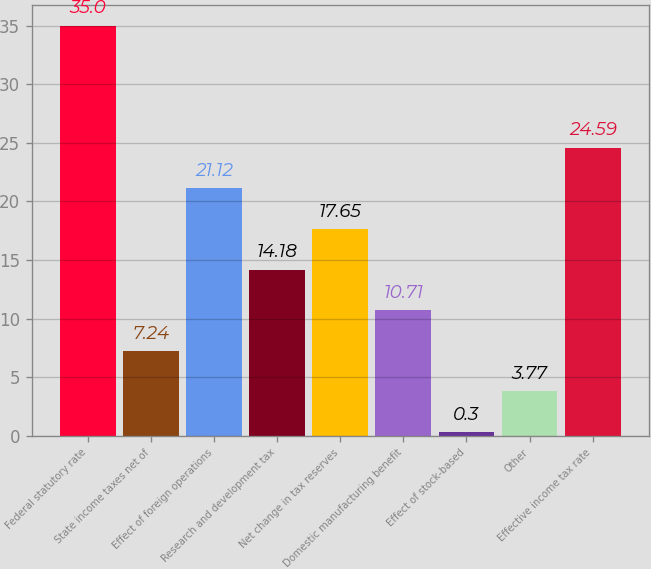<chart> <loc_0><loc_0><loc_500><loc_500><bar_chart><fcel>Federal statutory rate<fcel>State income taxes net of<fcel>Effect of foreign operations<fcel>Research and development tax<fcel>Net change in tax reserves<fcel>Domestic manufacturing benefit<fcel>Effect of stock-based<fcel>Other<fcel>Effective income tax rate<nl><fcel>35<fcel>7.24<fcel>21.12<fcel>14.18<fcel>17.65<fcel>10.71<fcel>0.3<fcel>3.77<fcel>24.59<nl></chart> 